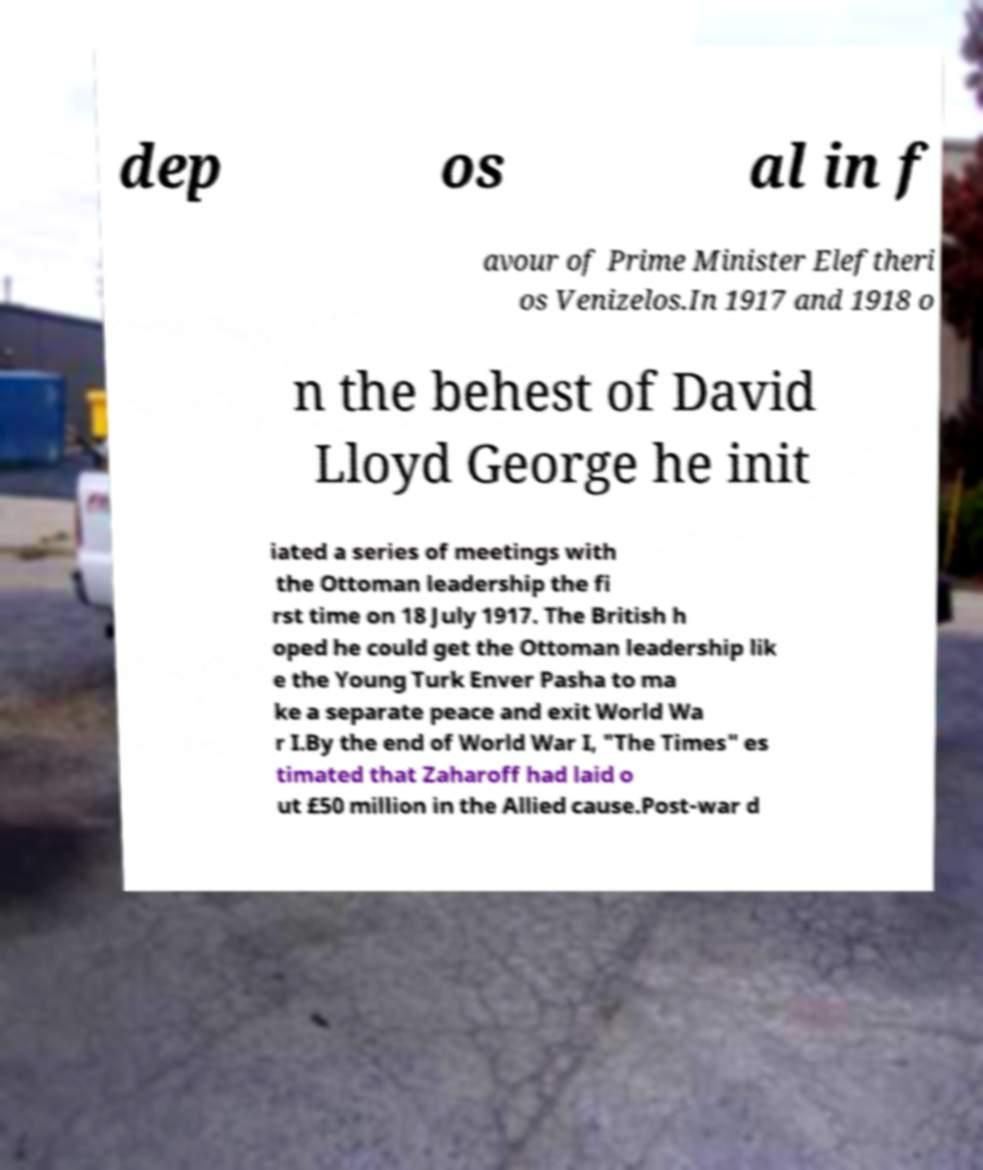Please read and relay the text visible in this image. What does it say? dep os al in f avour of Prime Minister Eleftheri os Venizelos.In 1917 and 1918 o n the behest of David Lloyd George he init iated a series of meetings with the Ottoman leadership the fi rst time on 18 July 1917. The British h oped he could get the Ottoman leadership lik e the Young Turk Enver Pasha to ma ke a separate peace and exit World Wa r I.By the end of World War I, "The Times" es timated that Zaharoff had laid o ut £50 million in the Allied cause.Post-war d 